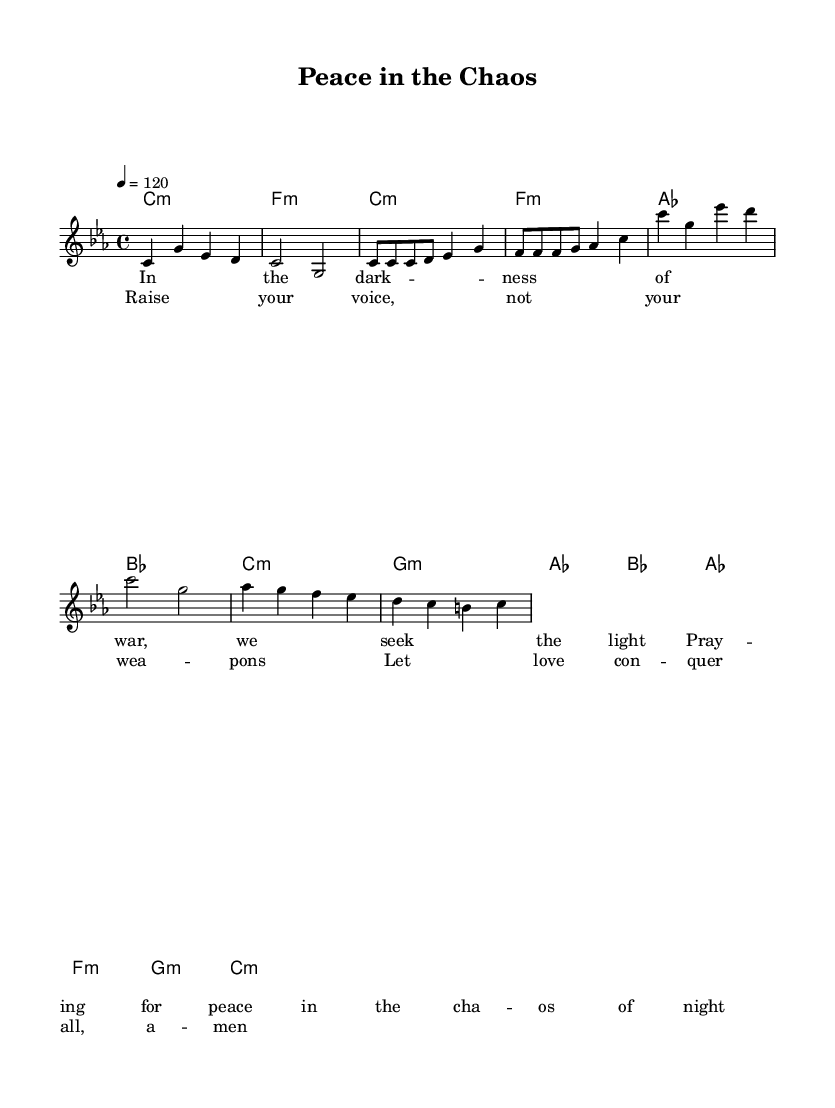What is the key signature of this music? The key signature is C minor, which consists of three flats: B♭, E♭, and A♭. This can be identified at the beginning of the staff.
Answer: C minor What is the time signature of this music? The time signature is 4/4, meaning there are four beats in each measure, and the quarter note gets one beat. This detail is indicated right after the clef symbol at the beginning of the music.
Answer: 4/4 What is the tempo marking for this piece? The piece has a tempo marking of 120 beats per minute, indicated by the tempo marking '4 = 120' in the global settings at the top. This indicates the speed at which the piece should be played.
Answer: 120 How many measures are in the melody section? The melody section consists of 12 measures. This can be counted by looking for the vertical lines on the staff, which indicate the end of each measure.
Answer: 12 What is the main theme of the lyrics? The lyrics focus on themes of peace and love, especially in the context of war. The verse speaks about seeking light in darkness, while the chorus emphasizes raising voices instead of weapons. This summary can be discerned from the provided lyrics text.
Answer: Peace What kind of harmony is used during the chorus? The chorus uses minor harmonies, as indicated by 'c1:m', 'g1:m', 'as1', and 'bes1' in the chord section. Minor harmonies often convey deeper, more emotional feelings, which match the song's themes of struggle and hope.
Answer: Minor What message is conveyed by the phrase "Raise your voice, not your weapons"? This phrase conveys a powerful anti-war message that promotes communication and love over violence. It aligns with the song's overall theme of seeking peace amid chaos, which can be inferred from the lyrics.
Answer: Anti-war 